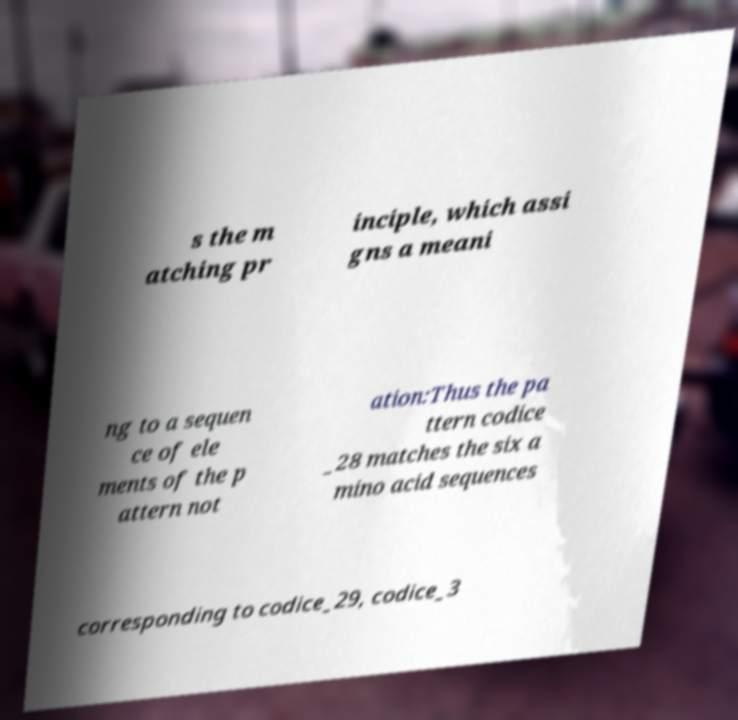I need the written content from this picture converted into text. Can you do that? s the m atching pr inciple, which assi gns a meani ng to a sequen ce of ele ments of the p attern not ation:Thus the pa ttern codice _28 matches the six a mino acid sequences corresponding to codice_29, codice_3 